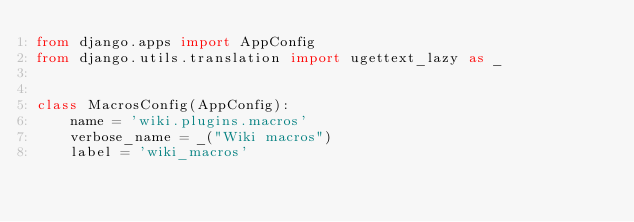Convert code to text. <code><loc_0><loc_0><loc_500><loc_500><_Python_>from django.apps import AppConfig
from django.utils.translation import ugettext_lazy as _


class MacrosConfig(AppConfig):
    name = 'wiki.plugins.macros'
    verbose_name = _("Wiki macros")
    label = 'wiki_macros'
</code> 